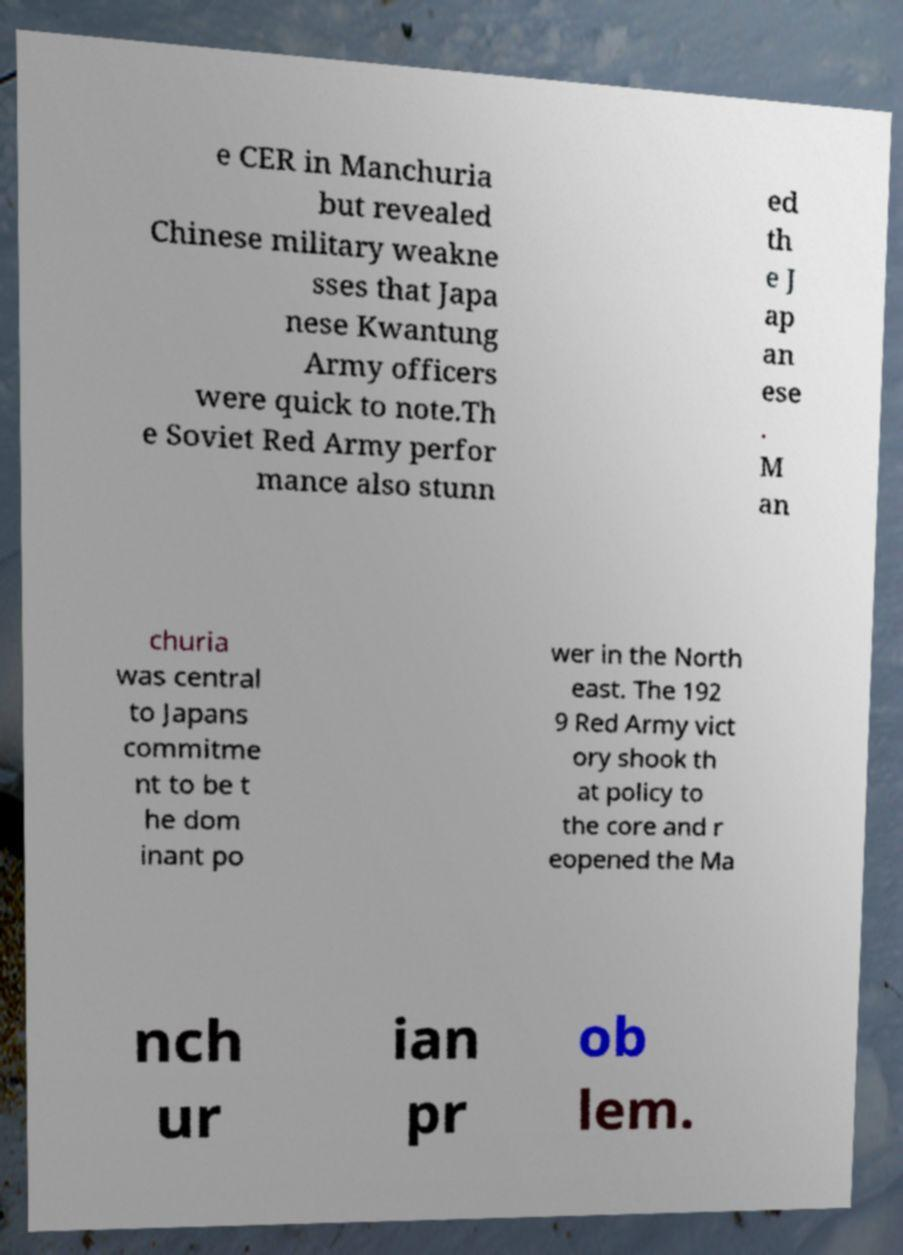There's text embedded in this image that I need extracted. Can you transcribe it verbatim? e CER in Manchuria but revealed Chinese military weakne sses that Japa nese Kwantung Army officers were quick to note.Th e Soviet Red Army perfor mance also stunn ed th e J ap an ese . M an churia was central to Japans commitme nt to be t he dom inant po wer in the North east. The 192 9 Red Army vict ory shook th at policy to the core and r eopened the Ma nch ur ian pr ob lem. 